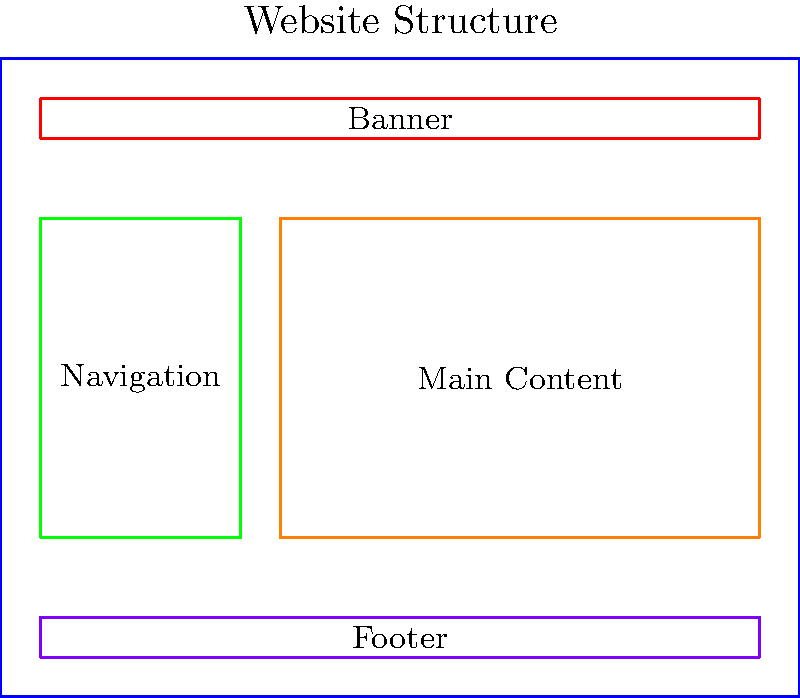Based on the website structure shown in the diagram, which ARIA landmark role should be applied to the green section to enhance accessibility for users relying on assistive technologies? To determine the appropriate ARIA landmark role for the green section, let's analyze the website structure step-by-step:

1. The diagram shows a typical website layout with four distinct sections:
   - Blue rectangle: Overall content area
   - Red rectangle: Banner (top)
   - Green rectangle: Left sidebar
   - Orange rectangle: Main content area
   - Purple rectangle: Footer (bottom)

2. ARIA landmarks are used to define the structure of a page for assistive technologies. The most common landmarks are:
   - banner: For the site header
   - navigation: For navigation menus
   - main: For the main content of the page
   - complementary: For supporting content
   - contentinfo: For footer information

3. The green section is positioned on the left side of the layout, which is a common placement for navigation menus.

4. The label "Navigation" is explicitly shown in the green section, confirming its purpose.

5. For users relying on assistive technologies, it's crucial to identify the navigation area clearly to allow easy access to different parts of the website.

6. The ARIA role that best describes a navigation menu is "navigation".

Therefore, the most appropriate ARIA landmark role for the green section is "navigation".
Answer: navigation 